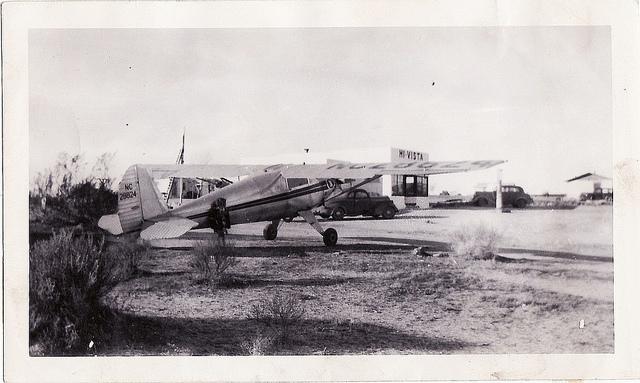Is this plane ready to take off?
Short answer required. Yes. How many wings does the plane have?
Quick response, please. 2. Is this a recent photo?
Answer briefly. No. Is this at an airport?
Keep it brief. No. What is on the ground besides the plane?
Concise answer only. Grass. 